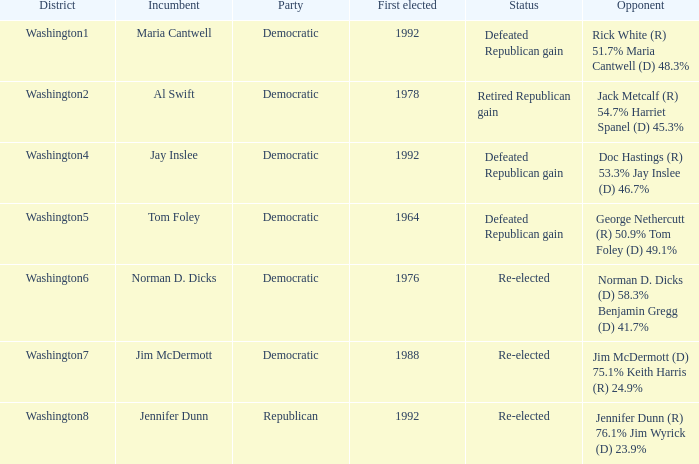What year was incumbent jim mcdermott first elected? 1988.0. 